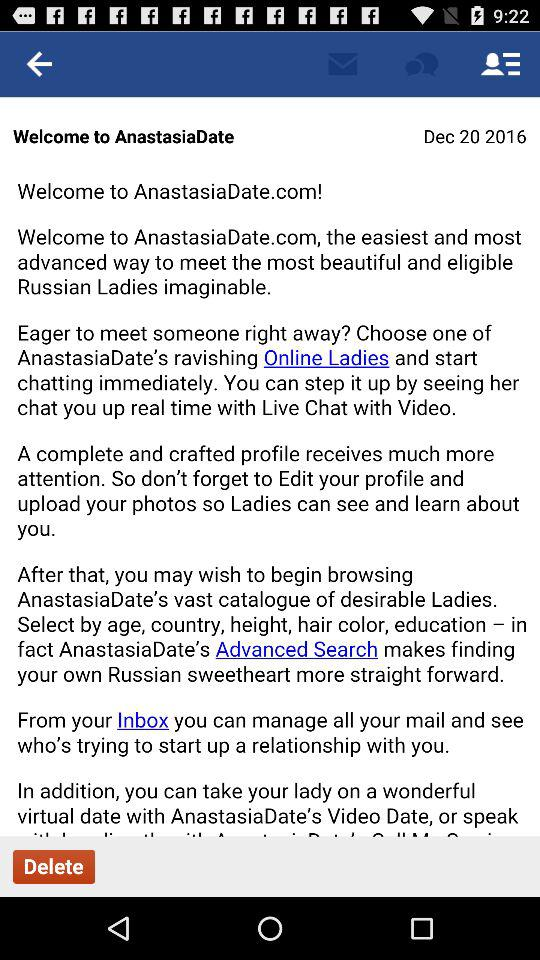What is the login name? The login name is John. 